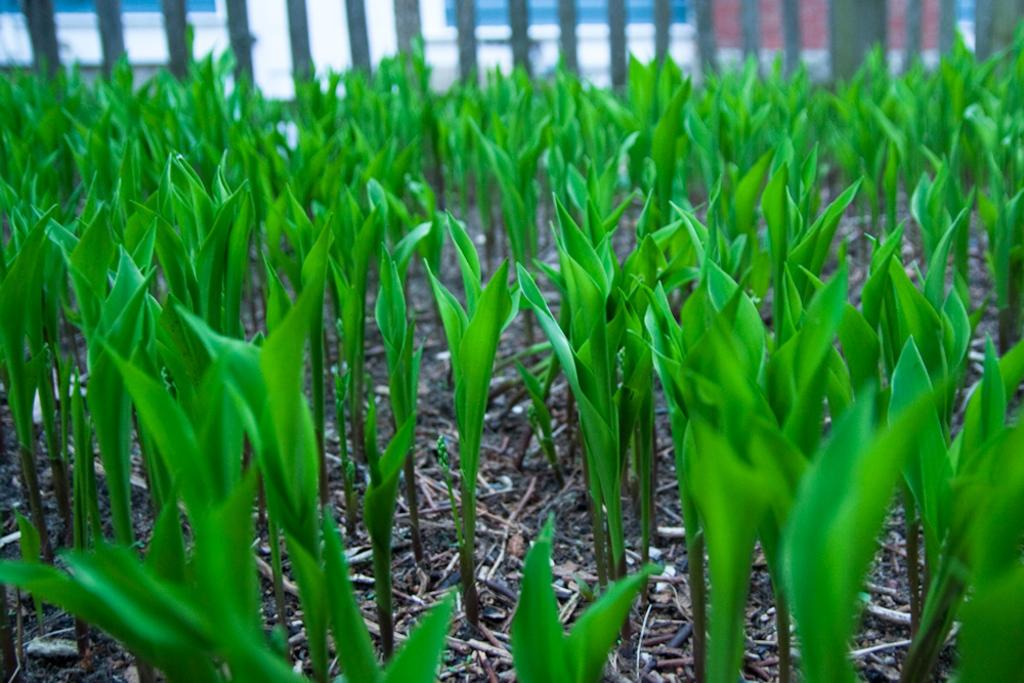What type of living organisms can be seen in the image? Plants can be seen in the image. What is visible in the background of the image? There is a fence in the background of the image. What type of rake is being used to maintain the plants in the image? There is no rake present in the image; it only features plants and a fence. What hobbies are the plants participating in within the image? Plants do not have hobbies, as they are living organisms and not capable of participating in hobbies. 